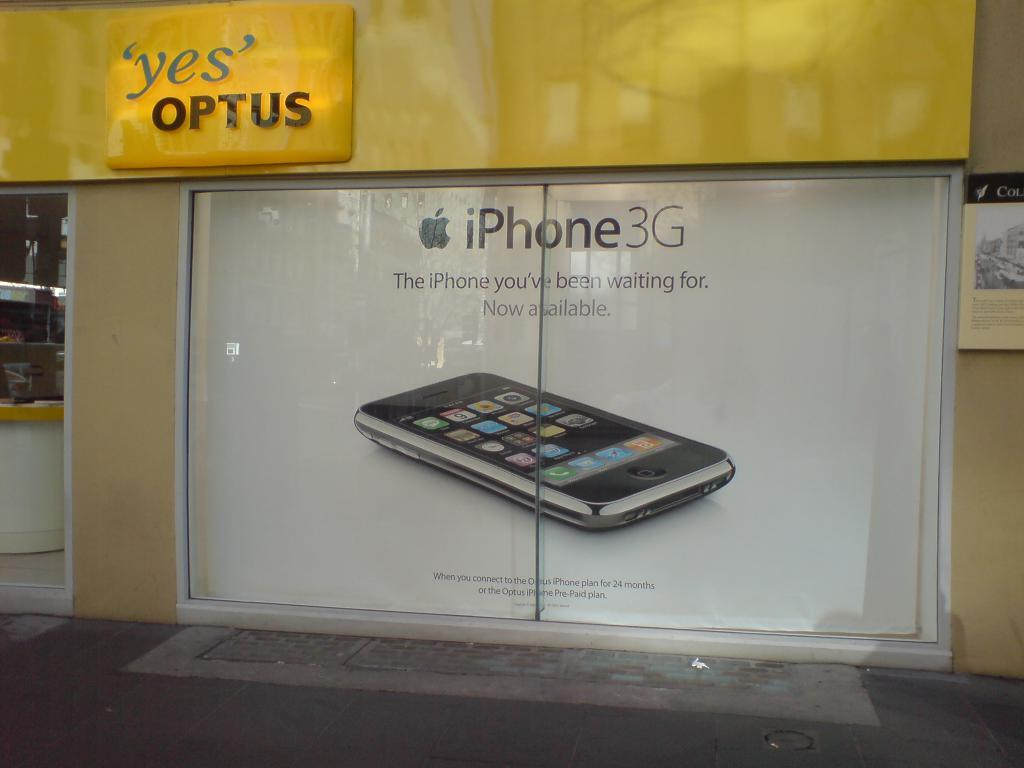What electronic device is visible in the image? There is an iPhone in the image. What is the color of the background in the image? The iPhone is on a white background. What other objects or features can be seen in the image? There is text on a door and a yellow color board in the image. What type of plot is being developed in the image? There is no plot development in the image; it is a still image featuring an iPhone, a white background, text on a door, and a yellow color board. 